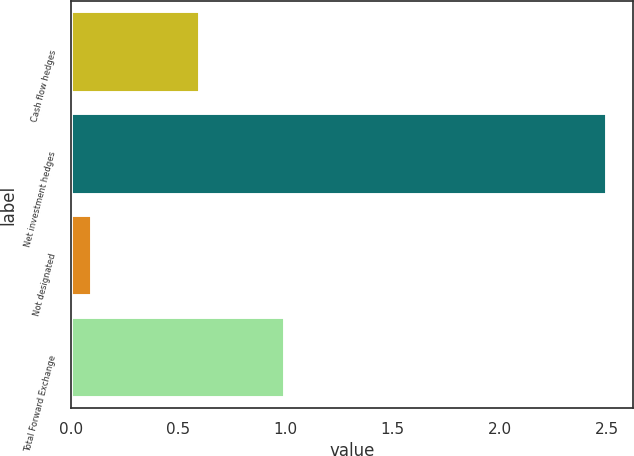Convert chart to OTSL. <chart><loc_0><loc_0><loc_500><loc_500><bar_chart><fcel>Cash flow hedges<fcel>Net investment hedges<fcel>Not designated<fcel>Total Forward Exchange<nl><fcel>0.6<fcel>2.5<fcel>0.1<fcel>1<nl></chart> 